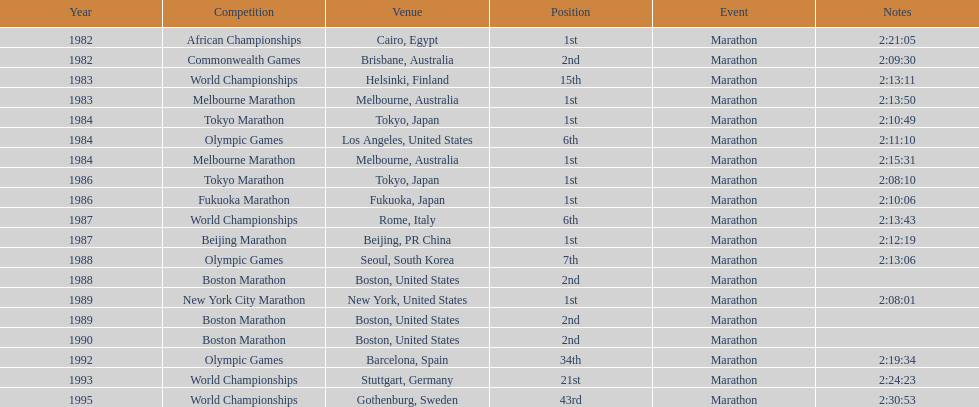Which was the only competition to occur in china? Beijing Marathon. 